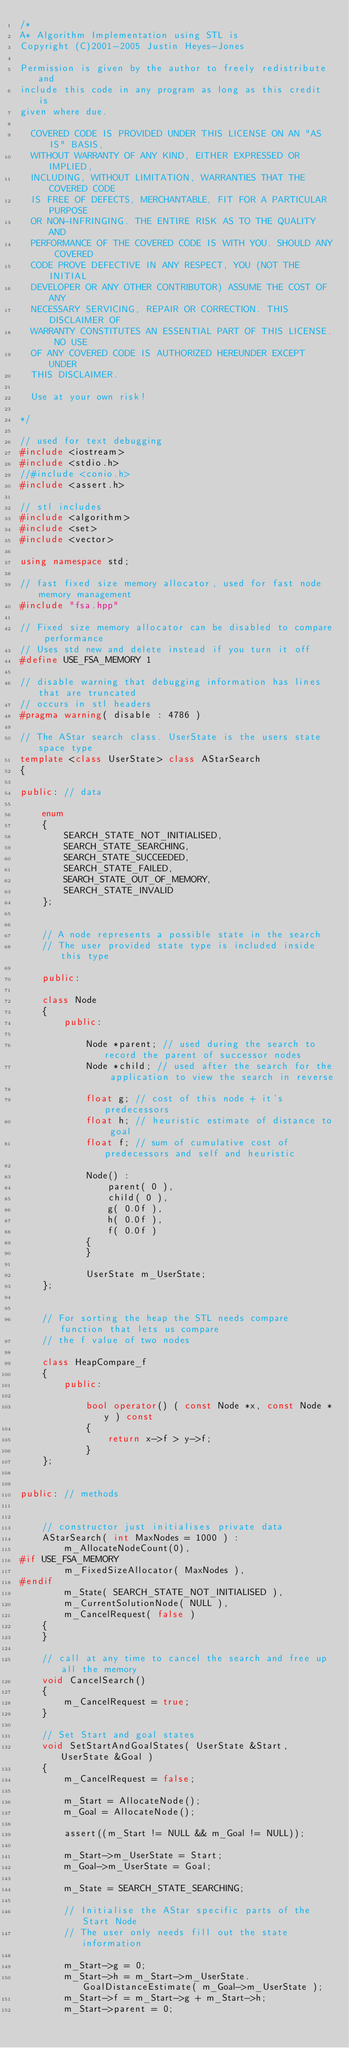<code> <loc_0><loc_0><loc_500><loc_500><_C++_>/*
A* Algorithm Implementation using STL is
Copyright (C)2001-2005 Justin Heyes-Jones

Permission is given by the author to freely redistribute and 
include this code in any program as long as this credit is 
given where due.
 
  COVERED CODE IS PROVIDED UNDER THIS LICENSE ON AN "AS IS" BASIS, 
  WITHOUT WARRANTY OF ANY KIND, EITHER EXPRESSED OR IMPLIED, 
  INCLUDING, WITHOUT LIMITATION, WARRANTIES THAT THE COVERED CODE 
  IS FREE OF DEFECTS, MERCHANTABLE, FIT FOR A PARTICULAR PURPOSE
  OR NON-INFRINGING. THE ENTIRE RISK AS TO THE QUALITY AND 
  PERFORMANCE OF THE COVERED CODE IS WITH YOU. SHOULD ANY COVERED 
  CODE PROVE DEFECTIVE IN ANY RESPECT, YOU (NOT THE INITIAL 
  DEVELOPER OR ANY OTHER CONTRIBUTOR) ASSUME THE COST OF ANY 
  NECESSARY SERVICING, REPAIR OR CORRECTION. THIS DISCLAIMER OF 
  WARRANTY CONSTITUTES AN ESSENTIAL PART OF THIS LICENSE. NO USE 
  OF ANY COVERED CODE IS AUTHORIZED HEREUNDER EXCEPT UNDER
  THIS DISCLAIMER.
 
  Use at your own risk!

*/

// used for text debugging
#include <iostream>
#include <stdio.h>
//#include <conio.h>
#include <assert.h>

// stl includes
#include <algorithm>
#include <set>
#include <vector>

using namespace std;

// fast fixed size memory allocator, used for fast node memory management
#include "fsa.hpp"

// Fixed size memory allocator can be disabled to compare performance
// Uses std new and delete instead if you turn it off
#define USE_FSA_MEMORY 1

// disable warning that debugging information has lines that are truncated
// occurs in stl headers
#pragma warning( disable : 4786 )

// The AStar search class. UserState is the users state space type
template <class UserState> class AStarSearch
{

public: // data

	enum
	{
		SEARCH_STATE_NOT_INITIALISED,
		SEARCH_STATE_SEARCHING,
		SEARCH_STATE_SUCCEEDED,
		SEARCH_STATE_FAILED,
		SEARCH_STATE_OUT_OF_MEMORY,
		SEARCH_STATE_INVALID
	};


	// A node represents a possible state in the search
	// The user provided state type is included inside this type

	public:

	class Node
	{
		public:

			Node *parent; // used during the search to record the parent of successor nodes
			Node *child; // used after the search for the application to view the search in reverse
			
			float g; // cost of this node + it's predecessors
			float h; // heuristic estimate of distance to goal
			float f; // sum of cumulative cost of predecessors and self and heuristic

			Node() :
				parent( 0 ),
				child( 0 ),
				g( 0.0f ),
				h( 0.0f ),
				f( 0.0f )
			{			
			}

			UserState m_UserState;
	};


	// For sorting the heap the STL needs compare function that lets us compare
	// the f value of two nodes

	class HeapCompare_f 
	{
		public:

			bool operator() ( const Node *x, const Node *y ) const
			{
				return x->f > y->f;
			}
	};


public: // methods


	// constructor just initialises private data
	AStarSearch( int MaxNodes = 1000 ) :
		m_AllocateNodeCount(0),
#if USE_FSA_MEMORY
		m_FixedSizeAllocator( MaxNodes ),
#endif
		m_State( SEARCH_STATE_NOT_INITIALISED ),
		m_CurrentSolutionNode( NULL ),
		m_CancelRequest( false )
	{
	}

	// call at any time to cancel the search and free up all the memory
	void CancelSearch()
	{
		m_CancelRequest = true;
	}

	// Set Start and goal states
	void SetStartAndGoalStates( UserState &Start, UserState &Goal )
	{
		m_CancelRequest = false;

		m_Start = AllocateNode();
		m_Goal = AllocateNode();

		assert((m_Start != NULL && m_Goal != NULL));
		
		m_Start->m_UserState = Start;
		m_Goal->m_UserState = Goal;

		m_State = SEARCH_STATE_SEARCHING;
		
		// Initialise the AStar specific parts of the Start Node
		// The user only needs fill out the state information

		m_Start->g = 0; 
		m_Start->h = m_Start->m_UserState.GoalDistanceEstimate( m_Goal->m_UserState );
		m_Start->f = m_Start->g + m_Start->h;
		m_Start->parent = 0;
</code> 